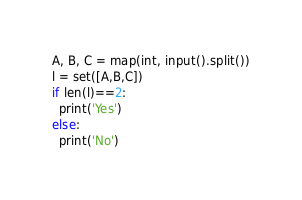Convert code to text. <code><loc_0><loc_0><loc_500><loc_500><_Python_>A, B, C = map(int, input().split())
l = set([A,B,C])
if len(l)==2:
  print('Yes')
else:
  print('No')</code> 